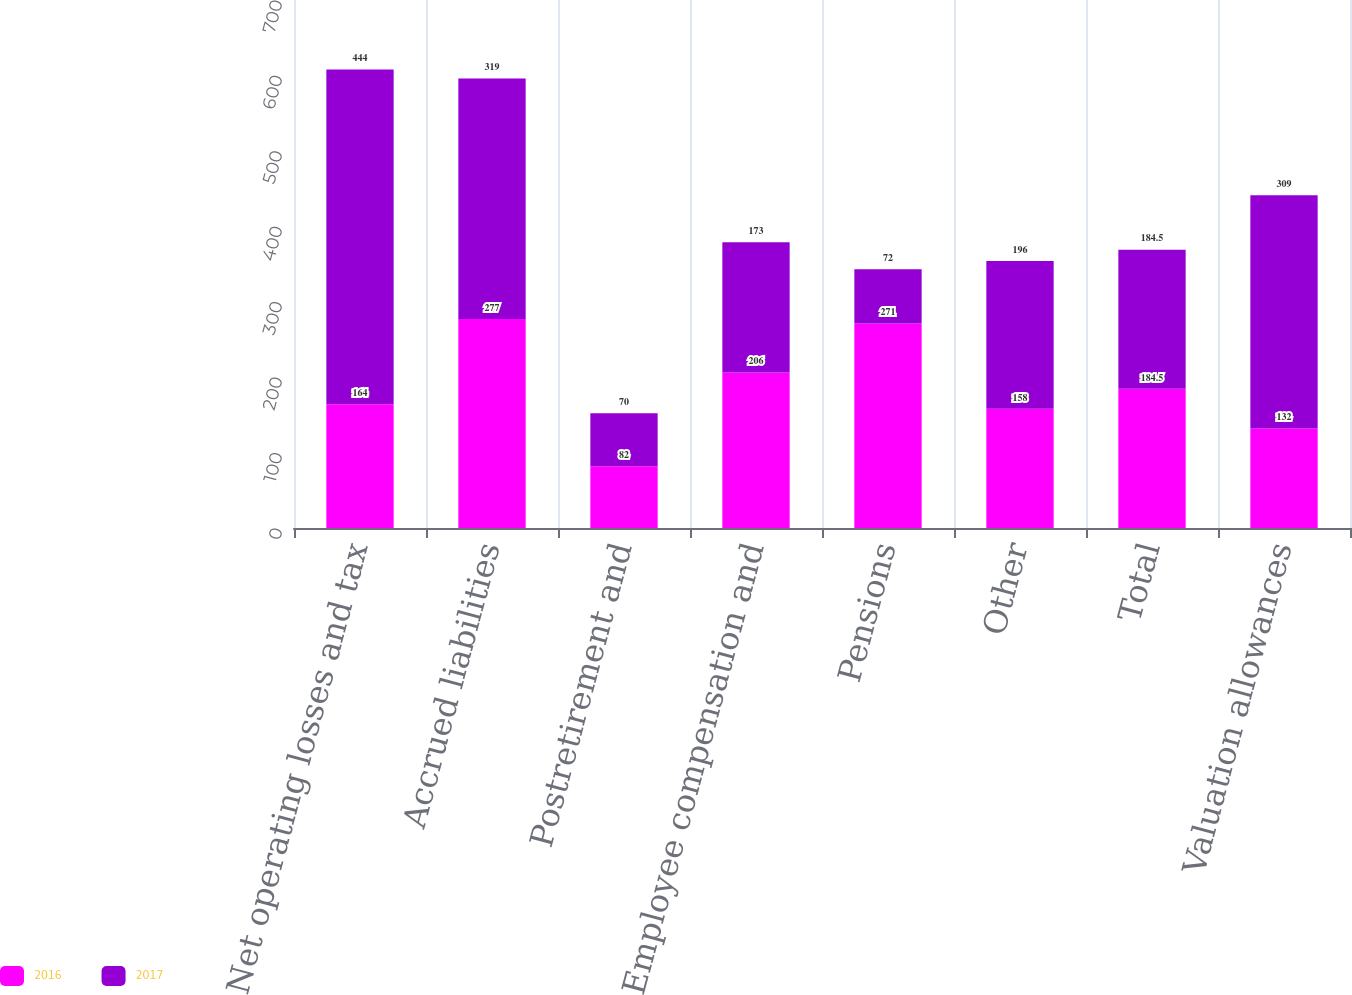<chart> <loc_0><loc_0><loc_500><loc_500><stacked_bar_chart><ecel><fcel>Net operating losses and tax<fcel>Accrued liabilities<fcel>Postretirement and<fcel>Employee compensation and<fcel>Pensions<fcel>Other<fcel>Total<fcel>Valuation allowances<nl><fcel>2016<fcel>164<fcel>277<fcel>82<fcel>206<fcel>271<fcel>158<fcel>184.5<fcel>132<nl><fcel>2017<fcel>444<fcel>319<fcel>70<fcel>173<fcel>72<fcel>196<fcel>184.5<fcel>309<nl></chart> 